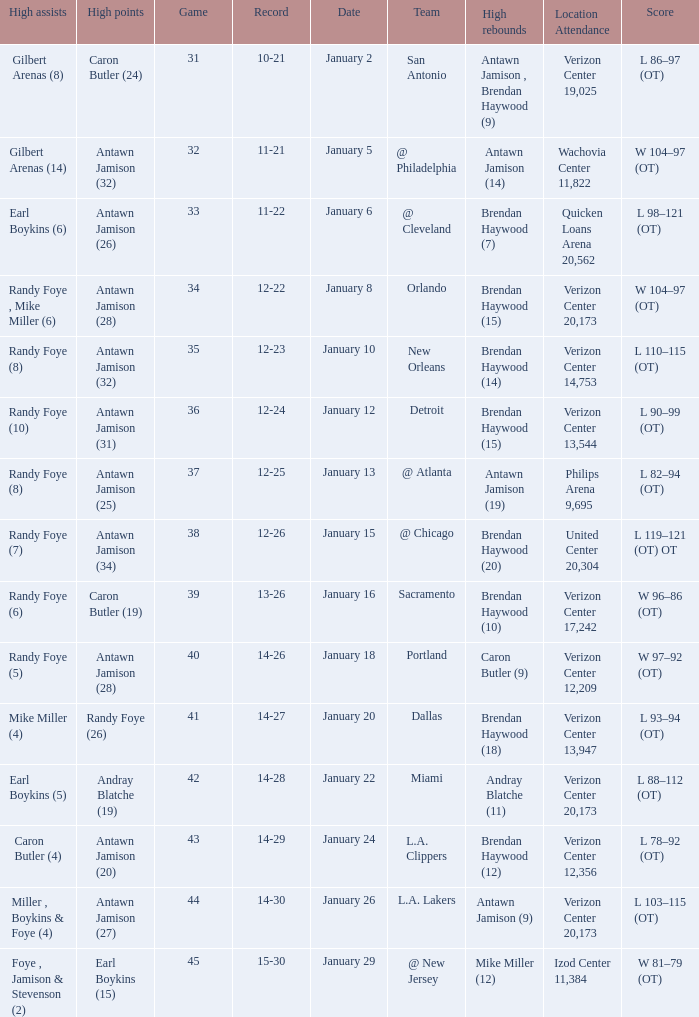Who had the highest points on January 2? Caron Butler (24). 